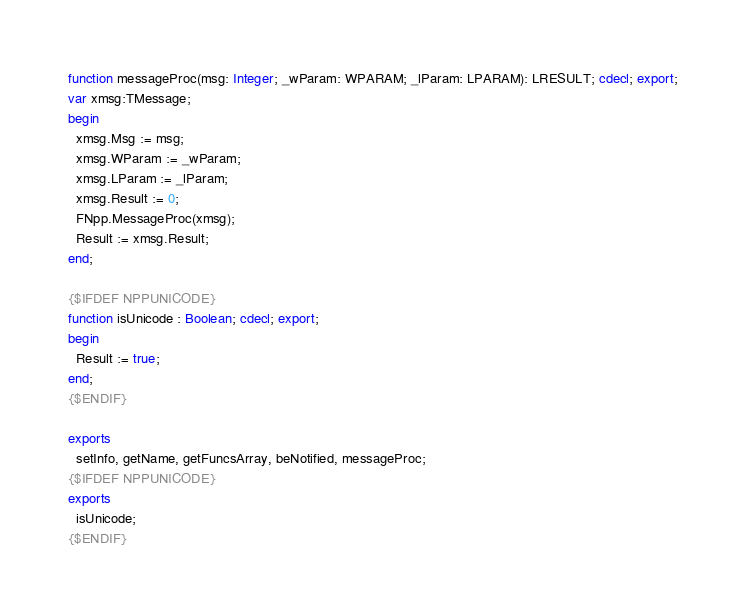Convert code to text. <code><loc_0><loc_0><loc_500><loc_500><_Pascal_>function messageProc(msg: Integer; _wParam: WPARAM; _lParam: LPARAM): LRESULT; cdecl; export;
var xmsg:TMessage;
begin
  xmsg.Msg := msg;
  xmsg.WParam := _wParam;
  xmsg.LParam := _lParam;
  xmsg.Result := 0;
  FNpp.MessageProc(xmsg);
  Result := xmsg.Result;
end;

{$IFDEF NPPUNICODE}
function isUnicode : Boolean; cdecl; export;
begin
  Result := true;
end;
{$ENDIF}

exports
  setInfo, getName, getFuncsArray, beNotified, messageProc;
{$IFDEF NPPUNICODE}
exports
  isUnicode;
{$ENDIF}
</code> 